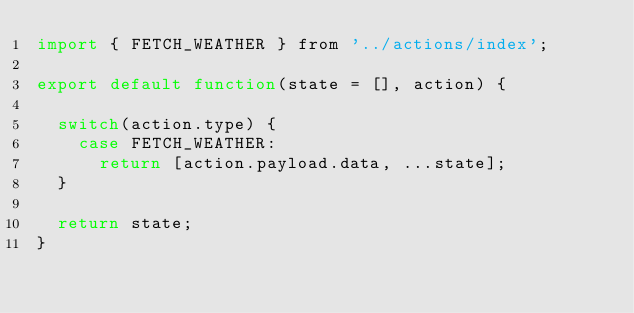<code> <loc_0><loc_0><loc_500><loc_500><_JavaScript_>import { FETCH_WEATHER } from '../actions/index';

export default function(state = [], action) {

  switch(action.type) {
    case FETCH_WEATHER:
      return [action.payload.data, ...state];
  }

  return state;
}</code> 